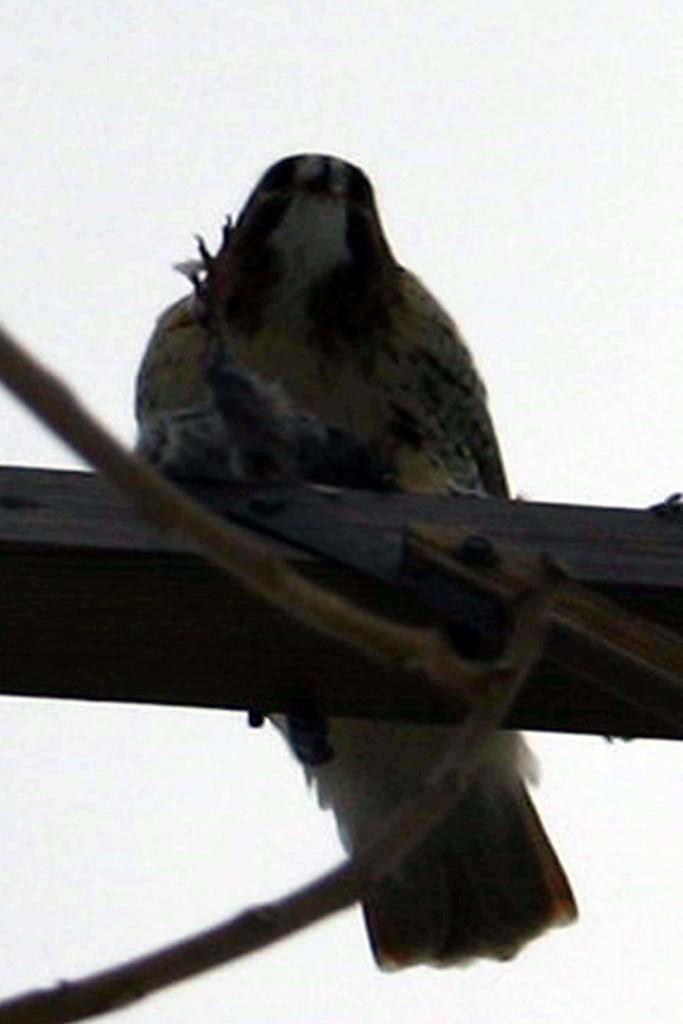Describe this image in one or two sentences. In this picture we can see a black color bird. Background portion of the picture is in white color. Here it seems like twigs. 